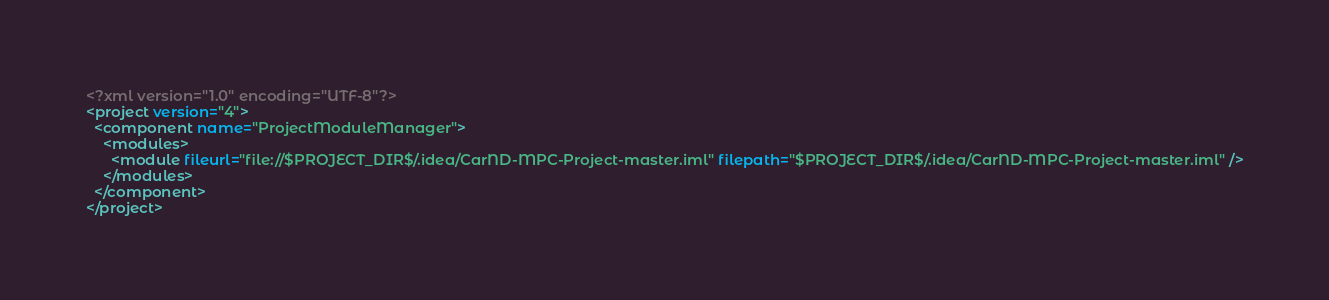Convert code to text. <code><loc_0><loc_0><loc_500><loc_500><_XML_><?xml version="1.0" encoding="UTF-8"?>
<project version="4">
  <component name="ProjectModuleManager">
    <modules>
      <module fileurl="file://$PROJECT_DIR$/.idea/CarND-MPC-Project-master.iml" filepath="$PROJECT_DIR$/.idea/CarND-MPC-Project-master.iml" />
    </modules>
  </component>
</project></code> 